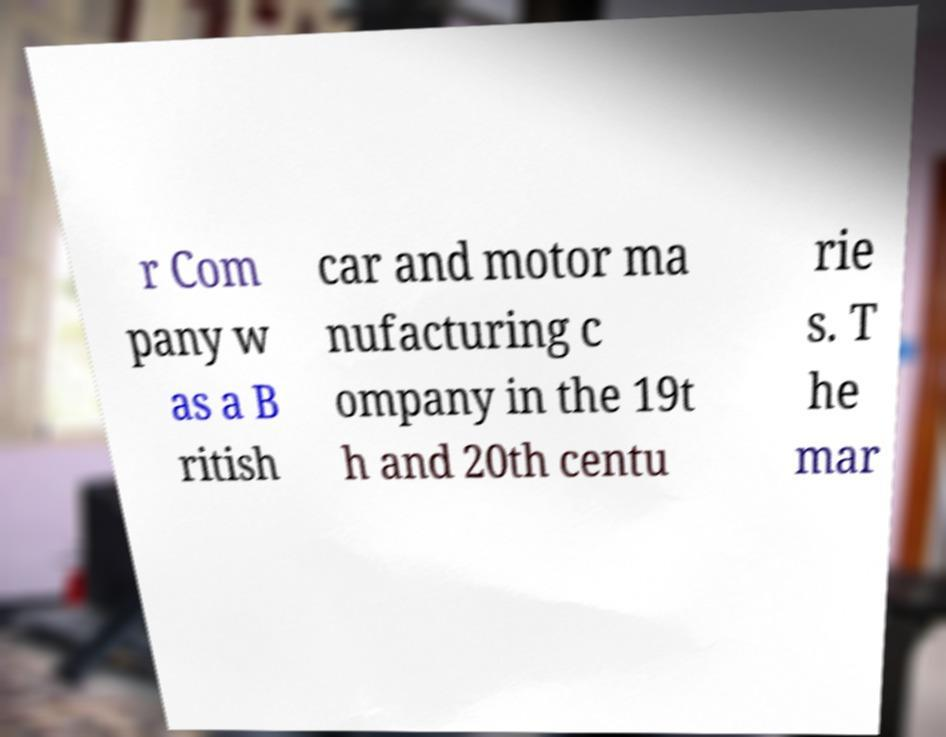Could you extract and type out the text from this image? r Com pany w as a B ritish car and motor ma nufacturing c ompany in the 19t h and 20th centu rie s. T he mar 